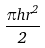Convert formula to latex. <formula><loc_0><loc_0><loc_500><loc_500>\frac { \pi h r ^ { 2 } } { 2 }</formula> 